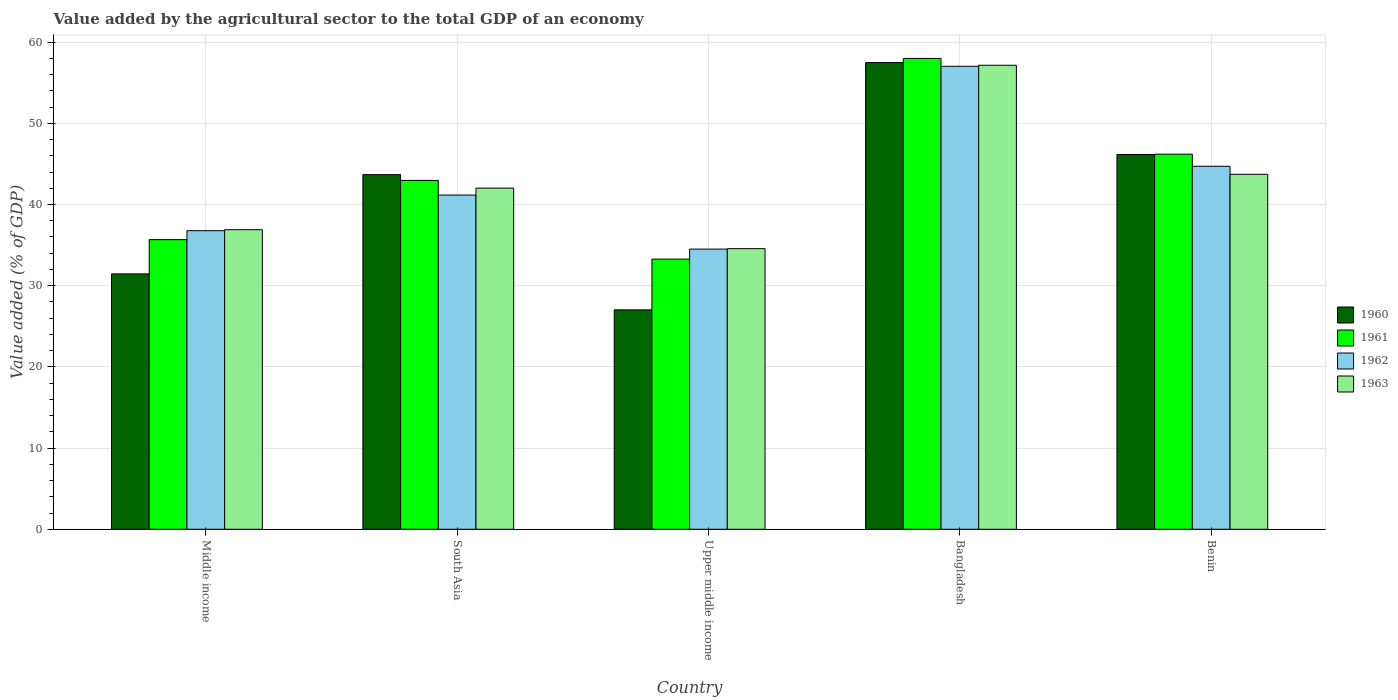How many groups of bars are there?
Offer a very short reply. 5. Are the number of bars on each tick of the X-axis equal?
Make the answer very short. Yes. How many bars are there on the 2nd tick from the left?
Provide a short and direct response. 4. What is the label of the 3rd group of bars from the left?
Offer a very short reply. Upper middle income. In how many cases, is the number of bars for a given country not equal to the number of legend labels?
Provide a short and direct response. 0. What is the value added by the agricultural sector to the total GDP in 1961 in South Asia?
Ensure brevity in your answer.  42.96. Across all countries, what is the maximum value added by the agricultural sector to the total GDP in 1961?
Your answer should be compact. 57.99. Across all countries, what is the minimum value added by the agricultural sector to the total GDP in 1963?
Keep it short and to the point. 34.56. In which country was the value added by the agricultural sector to the total GDP in 1961 minimum?
Provide a succinct answer. Upper middle income. What is the total value added by the agricultural sector to the total GDP in 1962 in the graph?
Give a very brief answer. 214.17. What is the difference between the value added by the agricultural sector to the total GDP in 1960 in Bangladesh and that in Middle income?
Your answer should be very brief. 26.02. What is the difference between the value added by the agricultural sector to the total GDP in 1960 in Benin and the value added by the agricultural sector to the total GDP in 1961 in South Asia?
Your answer should be very brief. 3.19. What is the average value added by the agricultural sector to the total GDP in 1962 per country?
Your answer should be compact. 42.83. What is the difference between the value added by the agricultural sector to the total GDP of/in 1962 and value added by the agricultural sector to the total GDP of/in 1960 in South Asia?
Make the answer very short. -2.52. What is the ratio of the value added by the agricultural sector to the total GDP in 1962 in Bangladesh to that in Middle income?
Your response must be concise. 1.55. What is the difference between the highest and the second highest value added by the agricultural sector to the total GDP in 1962?
Offer a very short reply. 12.31. What is the difference between the highest and the lowest value added by the agricultural sector to the total GDP in 1962?
Make the answer very short. 22.51. What does the 3rd bar from the left in Upper middle income represents?
Your answer should be very brief. 1962. Does the graph contain any zero values?
Keep it short and to the point. No. Where does the legend appear in the graph?
Keep it short and to the point. Center right. How many legend labels are there?
Make the answer very short. 4. How are the legend labels stacked?
Give a very brief answer. Vertical. What is the title of the graph?
Your answer should be compact. Value added by the agricultural sector to the total GDP of an economy. What is the label or title of the X-axis?
Provide a succinct answer. Country. What is the label or title of the Y-axis?
Your response must be concise. Value added (% of GDP). What is the Value added (% of GDP) in 1960 in Middle income?
Make the answer very short. 31.45. What is the Value added (% of GDP) of 1961 in Middle income?
Your answer should be compact. 35.67. What is the Value added (% of GDP) of 1962 in Middle income?
Provide a succinct answer. 36.77. What is the Value added (% of GDP) of 1963 in Middle income?
Provide a succinct answer. 36.89. What is the Value added (% of GDP) of 1960 in South Asia?
Make the answer very short. 43.68. What is the Value added (% of GDP) in 1961 in South Asia?
Keep it short and to the point. 42.96. What is the Value added (% of GDP) in 1962 in South Asia?
Your answer should be compact. 41.16. What is the Value added (% of GDP) in 1963 in South Asia?
Give a very brief answer. 42.02. What is the Value added (% of GDP) in 1960 in Upper middle income?
Provide a short and direct response. 27.02. What is the Value added (% of GDP) in 1961 in Upper middle income?
Your answer should be very brief. 33.27. What is the Value added (% of GDP) in 1962 in Upper middle income?
Keep it short and to the point. 34.5. What is the Value added (% of GDP) of 1963 in Upper middle income?
Provide a short and direct response. 34.56. What is the Value added (% of GDP) of 1960 in Bangladesh?
Make the answer very short. 57.47. What is the Value added (% of GDP) of 1961 in Bangladesh?
Your response must be concise. 57.99. What is the Value added (% of GDP) of 1962 in Bangladesh?
Your answer should be very brief. 57.02. What is the Value added (% of GDP) of 1963 in Bangladesh?
Keep it short and to the point. 57.15. What is the Value added (% of GDP) in 1960 in Benin?
Your response must be concise. 46.16. What is the Value added (% of GDP) in 1961 in Benin?
Your answer should be compact. 46.19. What is the Value added (% of GDP) in 1962 in Benin?
Ensure brevity in your answer.  44.71. What is the Value added (% of GDP) in 1963 in Benin?
Your answer should be compact. 43.72. Across all countries, what is the maximum Value added (% of GDP) in 1960?
Offer a terse response. 57.47. Across all countries, what is the maximum Value added (% of GDP) of 1961?
Your answer should be very brief. 57.99. Across all countries, what is the maximum Value added (% of GDP) in 1962?
Provide a succinct answer. 57.02. Across all countries, what is the maximum Value added (% of GDP) in 1963?
Your answer should be compact. 57.15. Across all countries, what is the minimum Value added (% of GDP) in 1960?
Make the answer very short. 27.02. Across all countries, what is the minimum Value added (% of GDP) in 1961?
Offer a very short reply. 33.27. Across all countries, what is the minimum Value added (% of GDP) in 1962?
Offer a terse response. 34.5. Across all countries, what is the minimum Value added (% of GDP) in 1963?
Keep it short and to the point. 34.56. What is the total Value added (% of GDP) of 1960 in the graph?
Ensure brevity in your answer.  205.78. What is the total Value added (% of GDP) in 1961 in the graph?
Provide a short and direct response. 216.09. What is the total Value added (% of GDP) of 1962 in the graph?
Provide a short and direct response. 214.17. What is the total Value added (% of GDP) in 1963 in the graph?
Provide a short and direct response. 214.34. What is the difference between the Value added (% of GDP) of 1960 in Middle income and that in South Asia?
Give a very brief answer. -12.22. What is the difference between the Value added (% of GDP) in 1961 in Middle income and that in South Asia?
Offer a very short reply. -7.29. What is the difference between the Value added (% of GDP) in 1962 in Middle income and that in South Asia?
Offer a terse response. -4.39. What is the difference between the Value added (% of GDP) of 1963 in Middle income and that in South Asia?
Make the answer very short. -5.13. What is the difference between the Value added (% of GDP) in 1960 in Middle income and that in Upper middle income?
Your response must be concise. 4.43. What is the difference between the Value added (% of GDP) of 1961 in Middle income and that in Upper middle income?
Provide a succinct answer. 2.4. What is the difference between the Value added (% of GDP) in 1962 in Middle income and that in Upper middle income?
Make the answer very short. 2.27. What is the difference between the Value added (% of GDP) of 1963 in Middle income and that in Upper middle income?
Give a very brief answer. 2.33. What is the difference between the Value added (% of GDP) of 1960 in Middle income and that in Bangladesh?
Give a very brief answer. -26.02. What is the difference between the Value added (% of GDP) of 1961 in Middle income and that in Bangladesh?
Offer a terse response. -22.32. What is the difference between the Value added (% of GDP) of 1962 in Middle income and that in Bangladesh?
Offer a very short reply. -20.24. What is the difference between the Value added (% of GDP) in 1963 in Middle income and that in Bangladesh?
Ensure brevity in your answer.  -20.25. What is the difference between the Value added (% of GDP) of 1960 in Middle income and that in Benin?
Keep it short and to the point. -14.71. What is the difference between the Value added (% of GDP) of 1961 in Middle income and that in Benin?
Keep it short and to the point. -10.52. What is the difference between the Value added (% of GDP) in 1962 in Middle income and that in Benin?
Provide a short and direct response. -7.94. What is the difference between the Value added (% of GDP) of 1963 in Middle income and that in Benin?
Your response must be concise. -6.82. What is the difference between the Value added (% of GDP) of 1960 in South Asia and that in Upper middle income?
Offer a terse response. 16.65. What is the difference between the Value added (% of GDP) of 1961 in South Asia and that in Upper middle income?
Ensure brevity in your answer.  9.69. What is the difference between the Value added (% of GDP) in 1962 in South Asia and that in Upper middle income?
Keep it short and to the point. 6.66. What is the difference between the Value added (% of GDP) in 1963 in South Asia and that in Upper middle income?
Provide a succinct answer. 7.46. What is the difference between the Value added (% of GDP) of 1960 in South Asia and that in Bangladesh?
Offer a terse response. -13.8. What is the difference between the Value added (% of GDP) in 1961 in South Asia and that in Bangladesh?
Make the answer very short. -15.02. What is the difference between the Value added (% of GDP) in 1962 in South Asia and that in Bangladesh?
Your answer should be very brief. -15.86. What is the difference between the Value added (% of GDP) in 1963 in South Asia and that in Bangladesh?
Your answer should be compact. -15.13. What is the difference between the Value added (% of GDP) of 1960 in South Asia and that in Benin?
Your response must be concise. -2.48. What is the difference between the Value added (% of GDP) in 1961 in South Asia and that in Benin?
Offer a terse response. -3.23. What is the difference between the Value added (% of GDP) in 1962 in South Asia and that in Benin?
Your response must be concise. -3.55. What is the difference between the Value added (% of GDP) of 1963 in South Asia and that in Benin?
Give a very brief answer. -1.7. What is the difference between the Value added (% of GDP) in 1960 in Upper middle income and that in Bangladesh?
Provide a short and direct response. -30.45. What is the difference between the Value added (% of GDP) in 1961 in Upper middle income and that in Bangladesh?
Provide a succinct answer. -24.71. What is the difference between the Value added (% of GDP) of 1962 in Upper middle income and that in Bangladesh?
Your answer should be very brief. -22.51. What is the difference between the Value added (% of GDP) in 1963 in Upper middle income and that in Bangladesh?
Offer a very short reply. -22.59. What is the difference between the Value added (% of GDP) in 1960 in Upper middle income and that in Benin?
Give a very brief answer. -19.14. What is the difference between the Value added (% of GDP) in 1961 in Upper middle income and that in Benin?
Offer a very short reply. -12.92. What is the difference between the Value added (% of GDP) of 1962 in Upper middle income and that in Benin?
Provide a succinct answer. -10.21. What is the difference between the Value added (% of GDP) of 1963 in Upper middle income and that in Benin?
Your answer should be compact. -9.16. What is the difference between the Value added (% of GDP) in 1960 in Bangladesh and that in Benin?
Keep it short and to the point. 11.32. What is the difference between the Value added (% of GDP) in 1961 in Bangladesh and that in Benin?
Ensure brevity in your answer.  11.79. What is the difference between the Value added (% of GDP) in 1962 in Bangladesh and that in Benin?
Your answer should be compact. 12.31. What is the difference between the Value added (% of GDP) of 1963 in Bangladesh and that in Benin?
Ensure brevity in your answer.  13.43. What is the difference between the Value added (% of GDP) of 1960 in Middle income and the Value added (% of GDP) of 1961 in South Asia?
Your answer should be compact. -11.51. What is the difference between the Value added (% of GDP) in 1960 in Middle income and the Value added (% of GDP) in 1962 in South Asia?
Offer a very short reply. -9.71. What is the difference between the Value added (% of GDP) of 1960 in Middle income and the Value added (% of GDP) of 1963 in South Asia?
Ensure brevity in your answer.  -10.57. What is the difference between the Value added (% of GDP) in 1961 in Middle income and the Value added (% of GDP) in 1962 in South Asia?
Your answer should be compact. -5.49. What is the difference between the Value added (% of GDP) of 1961 in Middle income and the Value added (% of GDP) of 1963 in South Asia?
Ensure brevity in your answer.  -6.35. What is the difference between the Value added (% of GDP) in 1962 in Middle income and the Value added (% of GDP) in 1963 in South Asia?
Provide a short and direct response. -5.25. What is the difference between the Value added (% of GDP) of 1960 in Middle income and the Value added (% of GDP) of 1961 in Upper middle income?
Your answer should be compact. -1.82. What is the difference between the Value added (% of GDP) in 1960 in Middle income and the Value added (% of GDP) in 1962 in Upper middle income?
Provide a short and direct response. -3.05. What is the difference between the Value added (% of GDP) of 1960 in Middle income and the Value added (% of GDP) of 1963 in Upper middle income?
Provide a short and direct response. -3.11. What is the difference between the Value added (% of GDP) of 1961 in Middle income and the Value added (% of GDP) of 1962 in Upper middle income?
Give a very brief answer. 1.17. What is the difference between the Value added (% of GDP) of 1961 in Middle income and the Value added (% of GDP) of 1963 in Upper middle income?
Offer a very short reply. 1.11. What is the difference between the Value added (% of GDP) of 1962 in Middle income and the Value added (% of GDP) of 1963 in Upper middle income?
Provide a succinct answer. 2.21. What is the difference between the Value added (% of GDP) of 1960 in Middle income and the Value added (% of GDP) of 1961 in Bangladesh?
Your response must be concise. -26.54. What is the difference between the Value added (% of GDP) of 1960 in Middle income and the Value added (% of GDP) of 1962 in Bangladesh?
Make the answer very short. -25.57. What is the difference between the Value added (% of GDP) in 1960 in Middle income and the Value added (% of GDP) in 1963 in Bangladesh?
Ensure brevity in your answer.  -25.7. What is the difference between the Value added (% of GDP) in 1961 in Middle income and the Value added (% of GDP) in 1962 in Bangladesh?
Give a very brief answer. -21.35. What is the difference between the Value added (% of GDP) of 1961 in Middle income and the Value added (% of GDP) of 1963 in Bangladesh?
Provide a short and direct response. -21.48. What is the difference between the Value added (% of GDP) of 1962 in Middle income and the Value added (% of GDP) of 1963 in Bangladesh?
Offer a terse response. -20.37. What is the difference between the Value added (% of GDP) of 1960 in Middle income and the Value added (% of GDP) of 1961 in Benin?
Your answer should be very brief. -14.74. What is the difference between the Value added (% of GDP) in 1960 in Middle income and the Value added (% of GDP) in 1962 in Benin?
Your answer should be very brief. -13.26. What is the difference between the Value added (% of GDP) in 1960 in Middle income and the Value added (% of GDP) in 1963 in Benin?
Your answer should be very brief. -12.27. What is the difference between the Value added (% of GDP) in 1961 in Middle income and the Value added (% of GDP) in 1962 in Benin?
Ensure brevity in your answer.  -9.04. What is the difference between the Value added (% of GDP) in 1961 in Middle income and the Value added (% of GDP) in 1963 in Benin?
Your answer should be very brief. -8.05. What is the difference between the Value added (% of GDP) of 1962 in Middle income and the Value added (% of GDP) of 1963 in Benin?
Ensure brevity in your answer.  -6.94. What is the difference between the Value added (% of GDP) of 1960 in South Asia and the Value added (% of GDP) of 1961 in Upper middle income?
Make the answer very short. 10.4. What is the difference between the Value added (% of GDP) in 1960 in South Asia and the Value added (% of GDP) in 1962 in Upper middle income?
Your answer should be compact. 9.17. What is the difference between the Value added (% of GDP) of 1960 in South Asia and the Value added (% of GDP) of 1963 in Upper middle income?
Your answer should be compact. 9.11. What is the difference between the Value added (% of GDP) of 1961 in South Asia and the Value added (% of GDP) of 1962 in Upper middle income?
Your response must be concise. 8.46. What is the difference between the Value added (% of GDP) of 1961 in South Asia and the Value added (% of GDP) of 1963 in Upper middle income?
Give a very brief answer. 8.4. What is the difference between the Value added (% of GDP) of 1962 in South Asia and the Value added (% of GDP) of 1963 in Upper middle income?
Provide a short and direct response. 6.6. What is the difference between the Value added (% of GDP) of 1960 in South Asia and the Value added (% of GDP) of 1961 in Bangladesh?
Make the answer very short. -14.31. What is the difference between the Value added (% of GDP) in 1960 in South Asia and the Value added (% of GDP) in 1962 in Bangladesh?
Give a very brief answer. -13.34. What is the difference between the Value added (% of GDP) in 1960 in South Asia and the Value added (% of GDP) in 1963 in Bangladesh?
Provide a short and direct response. -13.47. What is the difference between the Value added (% of GDP) of 1961 in South Asia and the Value added (% of GDP) of 1962 in Bangladesh?
Make the answer very short. -14.05. What is the difference between the Value added (% of GDP) in 1961 in South Asia and the Value added (% of GDP) in 1963 in Bangladesh?
Your answer should be very brief. -14.18. What is the difference between the Value added (% of GDP) in 1962 in South Asia and the Value added (% of GDP) in 1963 in Bangladesh?
Offer a very short reply. -15.99. What is the difference between the Value added (% of GDP) in 1960 in South Asia and the Value added (% of GDP) in 1961 in Benin?
Your response must be concise. -2.52. What is the difference between the Value added (% of GDP) in 1960 in South Asia and the Value added (% of GDP) in 1962 in Benin?
Your answer should be very brief. -1.03. What is the difference between the Value added (% of GDP) in 1960 in South Asia and the Value added (% of GDP) in 1963 in Benin?
Your answer should be compact. -0.04. What is the difference between the Value added (% of GDP) of 1961 in South Asia and the Value added (% of GDP) of 1962 in Benin?
Provide a short and direct response. -1.74. What is the difference between the Value added (% of GDP) of 1961 in South Asia and the Value added (% of GDP) of 1963 in Benin?
Your answer should be very brief. -0.75. What is the difference between the Value added (% of GDP) of 1962 in South Asia and the Value added (% of GDP) of 1963 in Benin?
Provide a succinct answer. -2.56. What is the difference between the Value added (% of GDP) of 1960 in Upper middle income and the Value added (% of GDP) of 1961 in Bangladesh?
Keep it short and to the point. -30.97. What is the difference between the Value added (% of GDP) of 1960 in Upper middle income and the Value added (% of GDP) of 1962 in Bangladesh?
Make the answer very short. -30. What is the difference between the Value added (% of GDP) in 1960 in Upper middle income and the Value added (% of GDP) in 1963 in Bangladesh?
Make the answer very short. -30.12. What is the difference between the Value added (% of GDP) of 1961 in Upper middle income and the Value added (% of GDP) of 1962 in Bangladesh?
Give a very brief answer. -23.74. What is the difference between the Value added (% of GDP) in 1961 in Upper middle income and the Value added (% of GDP) in 1963 in Bangladesh?
Your answer should be compact. -23.87. What is the difference between the Value added (% of GDP) in 1962 in Upper middle income and the Value added (% of GDP) in 1963 in Bangladesh?
Provide a short and direct response. -22.64. What is the difference between the Value added (% of GDP) of 1960 in Upper middle income and the Value added (% of GDP) of 1961 in Benin?
Your answer should be very brief. -19.17. What is the difference between the Value added (% of GDP) in 1960 in Upper middle income and the Value added (% of GDP) in 1962 in Benin?
Your response must be concise. -17.69. What is the difference between the Value added (% of GDP) of 1960 in Upper middle income and the Value added (% of GDP) of 1963 in Benin?
Your answer should be compact. -16.7. What is the difference between the Value added (% of GDP) of 1961 in Upper middle income and the Value added (% of GDP) of 1962 in Benin?
Keep it short and to the point. -11.43. What is the difference between the Value added (% of GDP) in 1961 in Upper middle income and the Value added (% of GDP) in 1963 in Benin?
Keep it short and to the point. -10.44. What is the difference between the Value added (% of GDP) of 1962 in Upper middle income and the Value added (% of GDP) of 1963 in Benin?
Your answer should be very brief. -9.21. What is the difference between the Value added (% of GDP) in 1960 in Bangladesh and the Value added (% of GDP) in 1961 in Benin?
Offer a very short reply. 11.28. What is the difference between the Value added (% of GDP) in 1960 in Bangladesh and the Value added (% of GDP) in 1962 in Benin?
Your answer should be compact. 12.77. What is the difference between the Value added (% of GDP) in 1960 in Bangladesh and the Value added (% of GDP) in 1963 in Benin?
Give a very brief answer. 13.76. What is the difference between the Value added (% of GDP) in 1961 in Bangladesh and the Value added (% of GDP) in 1962 in Benin?
Give a very brief answer. 13.28. What is the difference between the Value added (% of GDP) in 1961 in Bangladesh and the Value added (% of GDP) in 1963 in Benin?
Keep it short and to the point. 14.27. What is the difference between the Value added (% of GDP) of 1962 in Bangladesh and the Value added (% of GDP) of 1963 in Benin?
Offer a terse response. 13.3. What is the average Value added (% of GDP) in 1960 per country?
Your response must be concise. 41.16. What is the average Value added (% of GDP) in 1961 per country?
Provide a succinct answer. 43.22. What is the average Value added (% of GDP) in 1962 per country?
Provide a short and direct response. 42.83. What is the average Value added (% of GDP) of 1963 per country?
Provide a succinct answer. 42.87. What is the difference between the Value added (% of GDP) of 1960 and Value added (% of GDP) of 1961 in Middle income?
Your answer should be compact. -4.22. What is the difference between the Value added (% of GDP) in 1960 and Value added (% of GDP) in 1962 in Middle income?
Provide a short and direct response. -5.32. What is the difference between the Value added (% of GDP) in 1960 and Value added (% of GDP) in 1963 in Middle income?
Your response must be concise. -5.44. What is the difference between the Value added (% of GDP) of 1961 and Value added (% of GDP) of 1962 in Middle income?
Make the answer very short. -1.1. What is the difference between the Value added (% of GDP) in 1961 and Value added (% of GDP) in 1963 in Middle income?
Your answer should be very brief. -1.22. What is the difference between the Value added (% of GDP) of 1962 and Value added (% of GDP) of 1963 in Middle income?
Your answer should be very brief. -0.12. What is the difference between the Value added (% of GDP) in 1960 and Value added (% of GDP) in 1961 in South Asia?
Give a very brief answer. 0.71. What is the difference between the Value added (% of GDP) of 1960 and Value added (% of GDP) of 1962 in South Asia?
Offer a terse response. 2.52. What is the difference between the Value added (% of GDP) in 1960 and Value added (% of GDP) in 1963 in South Asia?
Offer a very short reply. 1.66. What is the difference between the Value added (% of GDP) in 1961 and Value added (% of GDP) in 1962 in South Asia?
Offer a terse response. 1.8. What is the difference between the Value added (% of GDP) of 1961 and Value added (% of GDP) of 1963 in South Asia?
Your answer should be compact. 0.95. What is the difference between the Value added (% of GDP) in 1962 and Value added (% of GDP) in 1963 in South Asia?
Offer a terse response. -0.86. What is the difference between the Value added (% of GDP) in 1960 and Value added (% of GDP) in 1961 in Upper middle income?
Keep it short and to the point. -6.25. What is the difference between the Value added (% of GDP) in 1960 and Value added (% of GDP) in 1962 in Upper middle income?
Ensure brevity in your answer.  -7.48. What is the difference between the Value added (% of GDP) of 1960 and Value added (% of GDP) of 1963 in Upper middle income?
Ensure brevity in your answer.  -7.54. What is the difference between the Value added (% of GDP) in 1961 and Value added (% of GDP) in 1962 in Upper middle income?
Give a very brief answer. -1.23. What is the difference between the Value added (% of GDP) of 1961 and Value added (% of GDP) of 1963 in Upper middle income?
Your answer should be compact. -1.29. What is the difference between the Value added (% of GDP) of 1962 and Value added (% of GDP) of 1963 in Upper middle income?
Your answer should be compact. -0.06. What is the difference between the Value added (% of GDP) of 1960 and Value added (% of GDP) of 1961 in Bangladesh?
Keep it short and to the point. -0.51. What is the difference between the Value added (% of GDP) in 1960 and Value added (% of GDP) in 1962 in Bangladesh?
Make the answer very short. 0.46. What is the difference between the Value added (% of GDP) in 1960 and Value added (% of GDP) in 1963 in Bangladesh?
Ensure brevity in your answer.  0.33. What is the difference between the Value added (% of GDP) in 1961 and Value added (% of GDP) in 1962 in Bangladesh?
Provide a succinct answer. 0.97. What is the difference between the Value added (% of GDP) in 1961 and Value added (% of GDP) in 1963 in Bangladesh?
Give a very brief answer. 0.84. What is the difference between the Value added (% of GDP) in 1962 and Value added (% of GDP) in 1963 in Bangladesh?
Offer a very short reply. -0.13. What is the difference between the Value added (% of GDP) of 1960 and Value added (% of GDP) of 1961 in Benin?
Provide a short and direct response. -0.04. What is the difference between the Value added (% of GDP) of 1960 and Value added (% of GDP) of 1962 in Benin?
Offer a terse response. 1.45. What is the difference between the Value added (% of GDP) of 1960 and Value added (% of GDP) of 1963 in Benin?
Provide a short and direct response. 2.44. What is the difference between the Value added (% of GDP) of 1961 and Value added (% of GDP) of 1962 in Benin?
Your answer should be very brief. 1.48. What is the difference between the Value added (% of GDP) of 1961 and Value added (% of GDP) of 1963 in Benin?
Offer a terse response. 2.48. What is the difference between the Value added (% of GDP) of 1962 and Value added (% of GDP) of 1963 in Benin?
Offer a very short reply. 0.99. What is the ratio of the Value added (% of GDP) of 1960 in Middle income to that in South Asia?
Provide a succinct answer. 0.72. What is the ratio of the Value added (% of GDP) of 1961 in Middle income to that in South Asia?
Provide a short and direct response. 0.83. What is the ratio of the Value added (% of GDP) in 1962 in Middle income to that in South Asia?
Your answer should be very brief. 0.89. What is the ratio of the Value added (% of GDP) in 1963 in Middle income to that in South Asia?
Ensure brevity in your answer.  0.88. What is the ratio of the Value added (% of GDP) of 1960 in Middle income to that in Upper middle income?
Your answer should be very brief. 1.16. What is the ratio of the Value added (% of GDP) of 1961 in Middle income to that in Upper middle income?
Give a very brief answer. 1.07. What is the ratio of the Value added (% of GDP) of 1962 in Middle income to that in Upper middle income?
Provide a short and direct response. 1.07. What is the ratio of the Value added (% of GDP) in 1963 in Middle income to that in Upper middle income?
Your answer should be compact. 1.07. What is the ratio of the Value added (% of GDP) in 1960 in Middle income to that in Bangladesh?
Your answer should be compact. 0.55. What is the ratio of the Value added (% of GDP) in 1961 in Middle income to that in Bangladesh?
Ensure brevity in your answer.  0.62. What is the ratio of the Value added (% of GDP) of 1962 in Middle income to that in Bangladesh?
Provide a succinct answer. 0.64. What is the ratio of the Value added (% of GDP) in 1963 in Middle income to that in Bangladesh?
Offer a terse response. 0.65. What is the ratio of the Value added (% of GDP) of 1960 in Middle income to that in Benin?
Offer a very short reply. 0.68. What is the ratio of the Value added (% of GDP) of 1961 in Middle income to that in Benin?
Make the answer very short. 0.77. What is the ratio of the Value added (% of GDP) of 1962 in Middle income to that in Benin?
Provide a short and direct response. 0.82. What is the ratio of the Value added (% of GDP) in 1963 in Middle income to that in Benin?
Your answer should be compact. 0.84. What is the ratio of the Value added (% of GDP) in 1960 in South Asia to that in Upper middle income?
Make the answer very short. 1.62. What is the ratio of the Value added (% of GDP) in 1961 in South Asia to that in Upper middle income?
Offer a terse response. 1.29. What is the ratio of the Value added (% of GDP) in 1962 in South Asia to that in Upper middle income?
Give a very brief answer. 1.19. What is the ratio of the Value added (% of GDP) of 1963 in South Asia to that in Upper middle income?
Your response must be concise. 1.22. What is the ratio of the Value added (% of GDP) of 1960 in South Asia to that in Bangladesh?
Ensure brevity in your answer.  0.76. What is the ratio of the Value added (% of GDP) in 1961 in South Asia to that in Bangladesh?
Provide a succinct answer. 0.74. What is the ratio of the Value added (% of GDP) in 1962 in South Asia to that in Bangladesh?
Ensure brevity in your answer.  0.72. What is the ratio of the Value added (% of GDP) of 1963 in South Asia to that in Bangladesh?
Provide a succinct answer. 0.74. What is the ratio of the Value added (% of GDP) of 1960 in South Asia to that in Benin?
Give a very brief answer. 0.95. What is the ratio of the Value added (% of GDP) in 1961 in South Asia to that in Benin?
Offer a terse response. 0.93. What is the ratio of the Value added (% of GDP) in 1962 in South Asia to that in Benin?
Keep it short and to the point. 0.92. What is the ratio of the Value added (% of GDP) in 1963 in South Asia to that in Benin?
Your answer should be very brief. 0.96. What is the ratio of the Value added (% of GDP) of 1960 in Upper middle income to that in Bangladesh?
Your answer should be compact. 0.47. What is the ratio of the Value added (% of GDP) of 1961 in Upper middle income to that in Bangladesh?
Your response must be concise. 0.57. What is the ratio of the Value added (% of GDP) in 1962 in Upper middle income to that in Bangladesh?
Your answer should be compact. 0.61. What is the ratio of the Value added (% of GDP) of 1963 in Upper middle income to that in Bangladesh?
Offer a terse response. 0.6. What is the ratio of the Value added (% of GDP) in 1960 in Upper middle income to that in Benin?
Offer a terse response. 0.59. What is the ratio of the Value added (% of GDP) of 1961 in Upper middle income to that in Benin?
Ensure brevity in your answer.  0.72. What is the ratio of the Value added (% of GDP) of 1962 in Upper middle income to that in Benin?
Offer a very short reply. 0.77. What is the ratio of the Value added (% of GDP) in 1963 in Upper middle income to that in Benin?
Offer a terse response. 0.79. What is the ratio of the Value added (% of GDP) of 1960 in Bangladesh to that in Benin?
Provide a short and direct response. 1.25. What is the ratio of the Value added (% of GDP) of 1961 in Bangladesh to that in Benin?
Provide a succinct answer. 1.26. What is the ratio of the Value added (% of GDP) in 1962 in Bangladesh to that in Benin?
Provide a short and direct response. 1.28. What is the ratio of the Value added (% of GDP) in 1963 in Bangladesh to that in Benin?
Ensure brevity in your answer.  1.31. What is the difference between the highest and the second highest Value added (% of GDP) of 1960?
Your response must be concise. 11.32. What is the difference between the highest and the second highest Value added (% of GDP) of 1961?
Offer a very short reply. 11.79. What is the difference between the highest and the second highest Value added (% of GDP) in 1962?
Provide a succinct answer. 12.31. What is the difference between the highest and the second highest Value added (% of GDP) in 1963?
Provide a short and direct response. 13.43. What is the difference between the highest and the lowest Value added (% of GDP) of 1960?
Offer a terse response. 30.45. What is the difference between the highest and the lowest Value added (% of GDP) in 1961?
Keep it short and to the point. 24.71. What is the difference between the highest and the lowest Value added (% of GDP) in 1962?
Keep it short and to the point. 22.51. What is the difference between the highest and the lowest Value added (% of GDP) in 1963?
Keep it short and to the point. 22.59. 